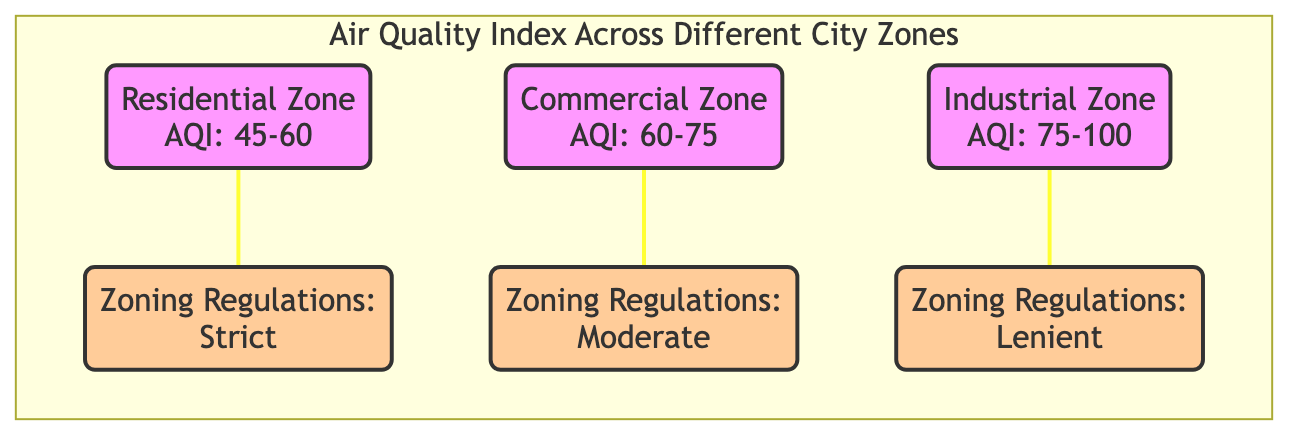What is the Air Quality Index (AQI) range for the residential zone? The diagram shows that the AQI range for the residential zone is 45-60. This information is directly displayed in the node representing the residential zone.
Answer: 45-60 Which zone has the highest Air Quality Index (AQI)? The industrial zone has the highest AQI as indicated by the range of 75-100 in its node. When comparing the AQI ranges of the three zones, the industrial zone's range is the highest.
Answer: Industrial Zone What type of zoning regulations does the commercial zone have? The diagram states that the commercial zone has moderate zoning regulations, which is displayed in the respective node connected to the commercial zone.
Answer: Moderate How many zones are represented in the diagram? The diagram includes three distinct zones: residential, commercial, and industrial. This can be counted by identifying the respective nodes.
Answer: 3 What is the relationship between industrial zones and zoning regulations? The industrial zone is connected to lenient zoning regulations as delineated in the diagram. This establishes a link between the industrial zone and its relaxed regulatory framework.
Answer: Lenient Which zone has the lowest pollution level based on the AQI? The residential zone shows the lowest pollution level with an AQI range of 45-60. A comparison of AQI ranges indicates that this zone has the most favorable condition.
Answer: Residential Zone Which zone is subject to strict zoning regulations? The strict zoning regulations apply to the residential zone, as displayed in the diagram. The residential zone's specific regulation type is clearly stated in its connecting node.
Answer: Residential Zone What is the AQI range for the commercial zone? The AQI range for the commercial zone is 60-75, indicated in the respective node for this zone within the diagram.
Answer: 60-75 What type of zoning regulations does the industrial zone have? The industrial zone is associated with lenient zoning regulations, as shown in its connected node within the diagram. This specifies the level of control over this zone's development.
Answer: Lenient 